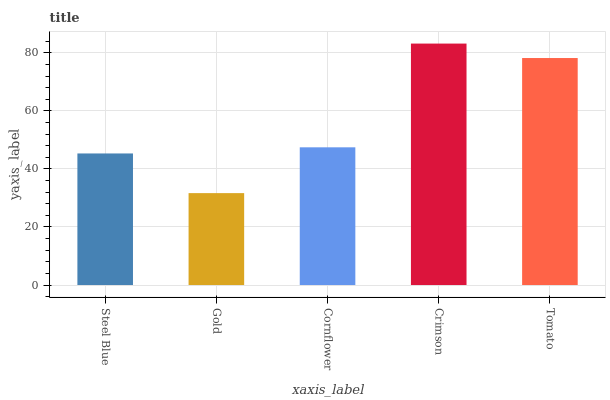Is Gold the minimum?
Answer yes or no. Yes. Is Crimson the maximum?
Answer yes or no. Yes. Is Cornflower the minimum?
Answer yes or no. No. Is Cornflower the maximum?
Answer yes or no. No. Is Cornflower greater than Gold?
Answer yes or no. Yes. Is Gold less than Cornflower?
Answer yes or no. Yes. Is Gold greater than Cornflower?
Answer yes or no. No. Is Cornflower less than Gold?
Answer yes or no. No. Is Cornflower the high median?
Answer yes or no. Yes. Is Cornflower the low median?
Answer yes or no. Yes. Is Tomato the high median?
Answer yes or no. No. Is Steel Blue the low median?
Answer yes or no. No. 